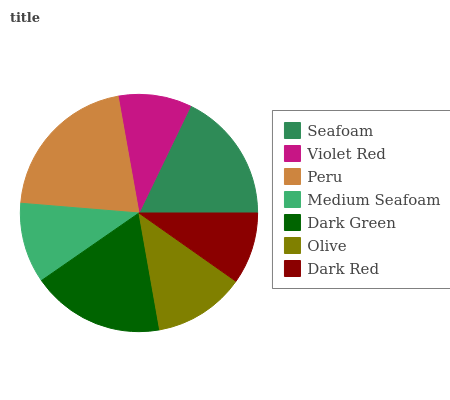Is Dark Red the minimum?
Answer yes or no. Yes. Is Peru the maximum?
Answer yes or no. Yes. Is Violet Red the minimum?
Answer yes or no. No. Is Violet Red the maximum?
Answer yes or no. No. Is Seafoam greater than Violet Red?
Answer yes or no. Yes. Is Violet Red less than Seafoam?
Answer yes or no. Yes. Is Violet Red greater than Seafoam?
Answer yes or no. No. Is Seafoam less than Violet Red?
Answer yes or no. No. Is Olive the high median?
Answer yes or no. Yes. Is Olive the low median?
Answer yes or no. Yes. Is Seafoam the high median?
Answer yes or no. No. Is Dark Red the low median?
Answer yes or no. No. 